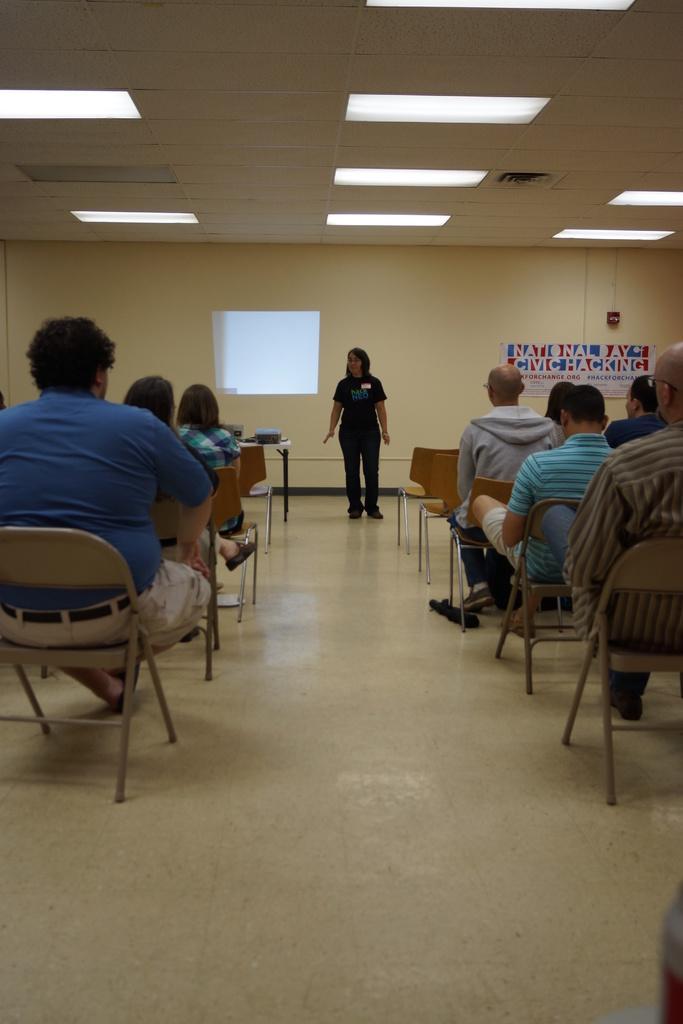Please provide a concise description of this image. This picture describes about group of people few are seated on the chair and one person is standing in front of them, and we can see a hoarding, projector screen and couple of lights in the room. 